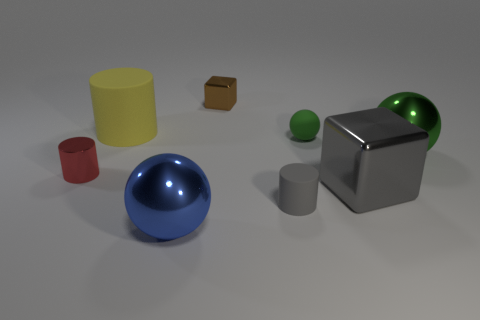Subtract all metal balls. How many balls are left? 1 Add 1 large brown rubber cylinders. How many objects exist? 9 Subtract all cylinders. How many objects are left? 5 Subtract all cyan shiny objects. Subtract all big gray shiny blocks. How many objects are left? 7 Add 6 tiny gray rubber objects. How many tiny gray rubber objects are left? 7 Add 7 large purple rubber cylinders. How many large purple rubber cylinders exist? 7 Subtract 0 blue cubes. How many objects are left? 8 